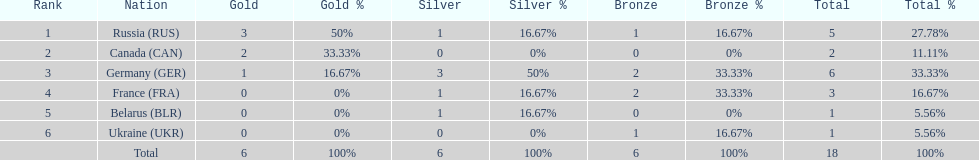What were the only 3 countries to win gold medals at the the 1994 winter olympics biathlon? Russia (RUS), Canada (CAN), Germany (GER). 